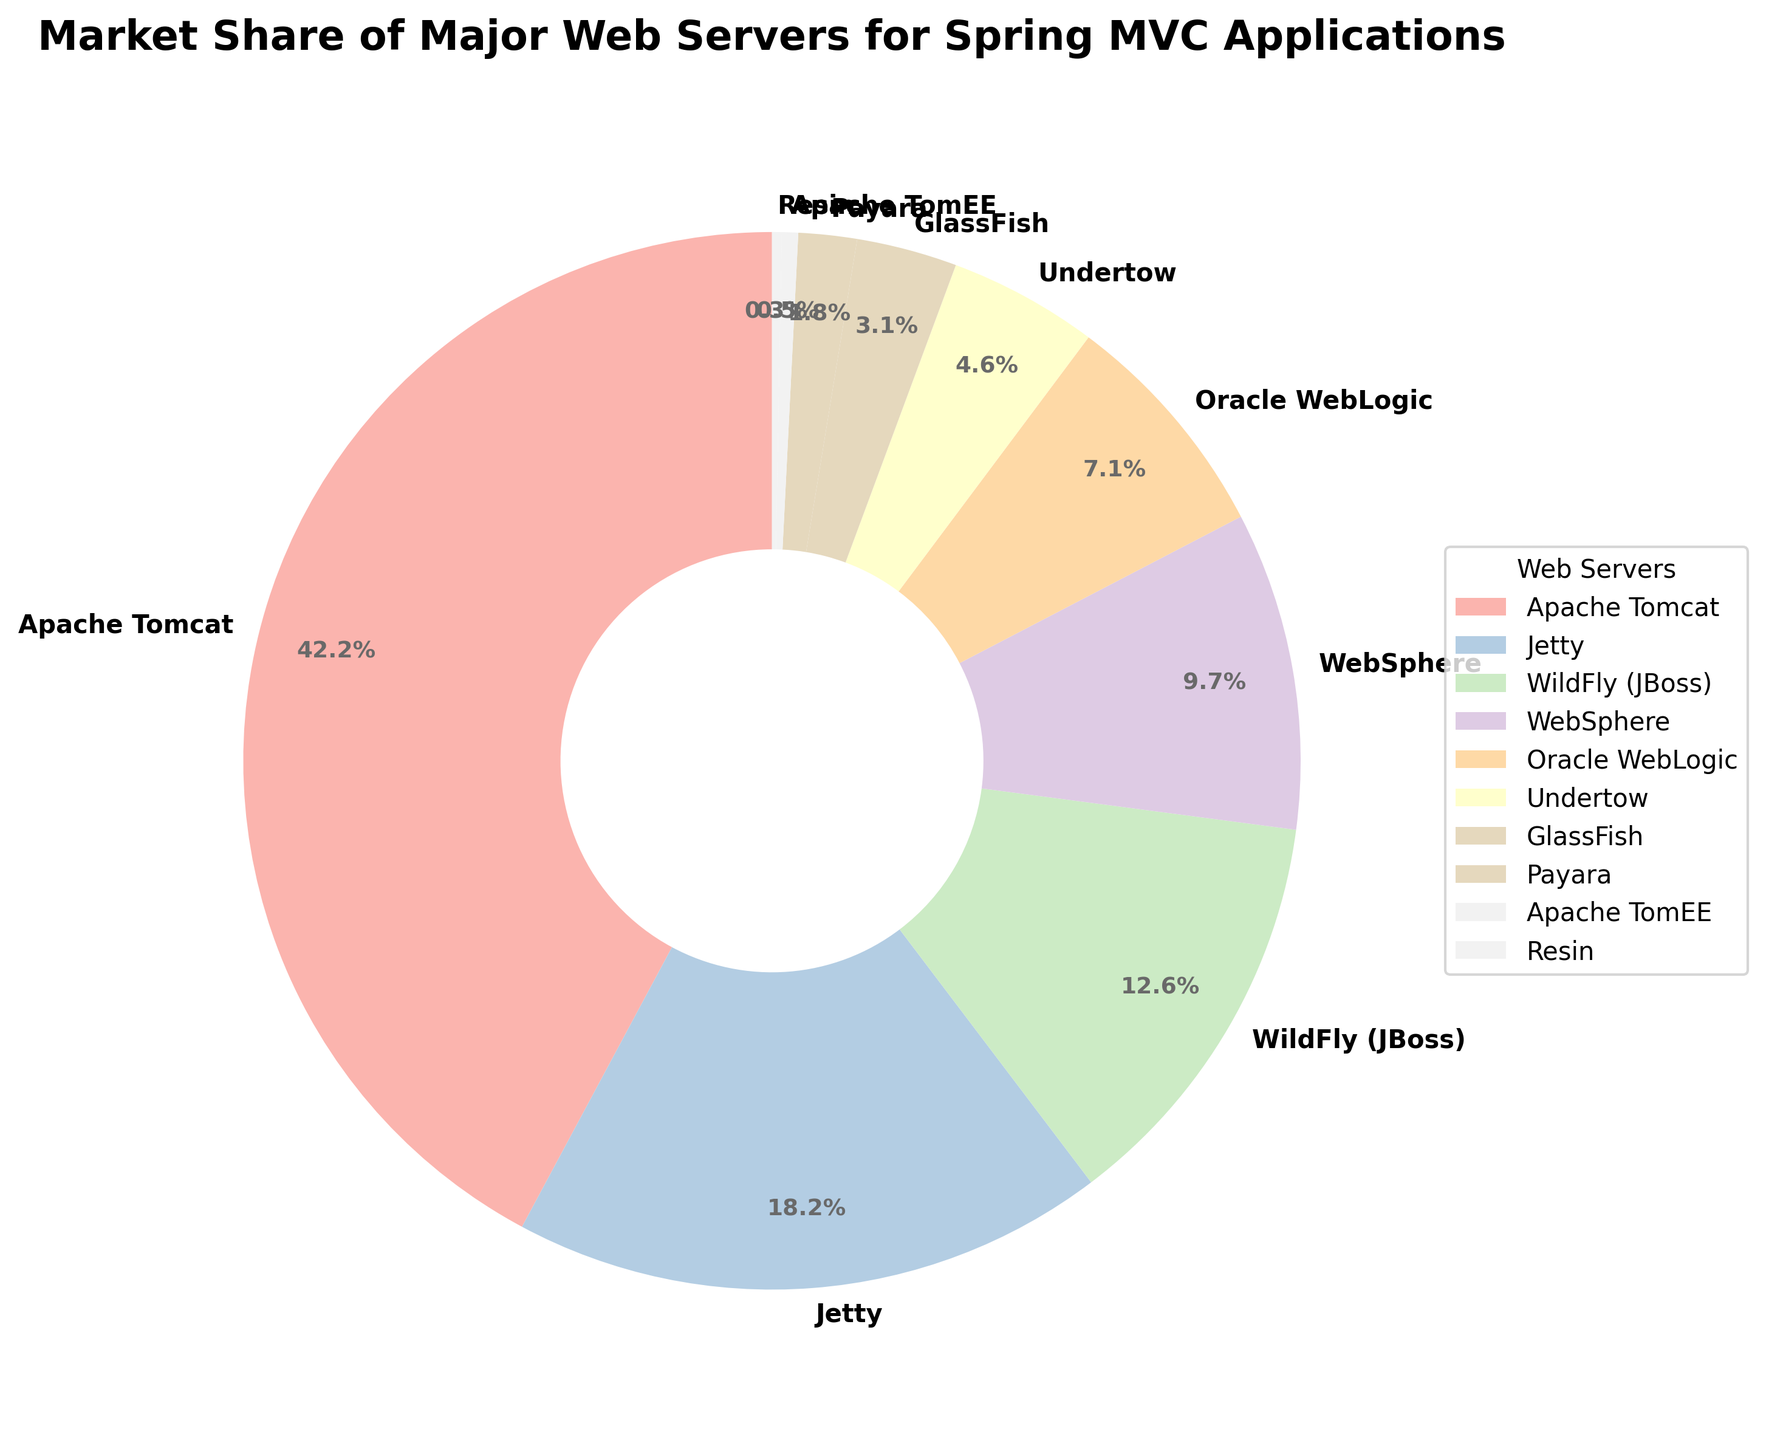What is the market share of Apache Tomcat? The market share of Apache Tomcat can be directly read from the chart. It is represented by the largest segment.
Answer: 42.5% Which web server has the smallest market share? The web server with the smallest market share is represented by the smallest segment in the pie chart. This segment is Apache TomEE.
Answer: Apache TomEE Combined market share of Jetty and WebSphere? Jetty's market share is 18.3% and WebSphere's is 9.8%. Adding them gives 18.3% + 9.8% = 28.1%.
Answer: 28.1% How much higher is the market share of Apache Tomcat compared to WildFly (JBoss)? Apache Tomcat has a market share of 42.5% and WildFly (JBoss) has 12.7%. The difference is 42.5% - 12.7% = 29.8%.
Answer: 29.8% Which web server has a higher market share, Undertow or GlassFish? Comparing the market share values, Undertow has 4.6% and GlassFish has 3.1%. Therefore, Undertow has a higher market share.
Answer: Undertow What is the combined market share of the servers with less than 10% market share each? Summing the shares of WebSphere (9.8%), Oracle WebLogic (7.2%), Undertow (4.6%), GlassFish (3.1%), Payara (1.8%), Apache TomEE (0.5%), and Resin (0.3%): 9.8 + 7.2 + 4.6 + 3.1 + 1.8 + 0.5 + 0.3 = 27.3%.
Answer: 27.3% How many web servers have a market share of more than 10%? Apache Tomcat (42.5%), Jetty (18.3%), and WildFly (JBoss) (12.7%) each have a market share of more than 10%. Therefore, there are three such web servers.
Answer: 3 What is the difference between the market share of the largest and smallest web servers? The largest market share is Apache Tomcat (42.5%), and the smallest is Apache TomEE (0.5%). The difference is 42.5% - 0.5% = 42%.
Answer: 42% Which web server segment is represented next to Oracle WebLogic clockwise? The chart indicates the order of segments. WebSphere is next to Oracle WebLogic in the clockwise direction.
Answer: WebSphere Which server has attributive visual representation that is represented by a large circle of one segment? The specific large circle segment represents Apache Tomcat due to its highest market share depicted prominently and significantly larger.
Answer: Apache Tomcat 